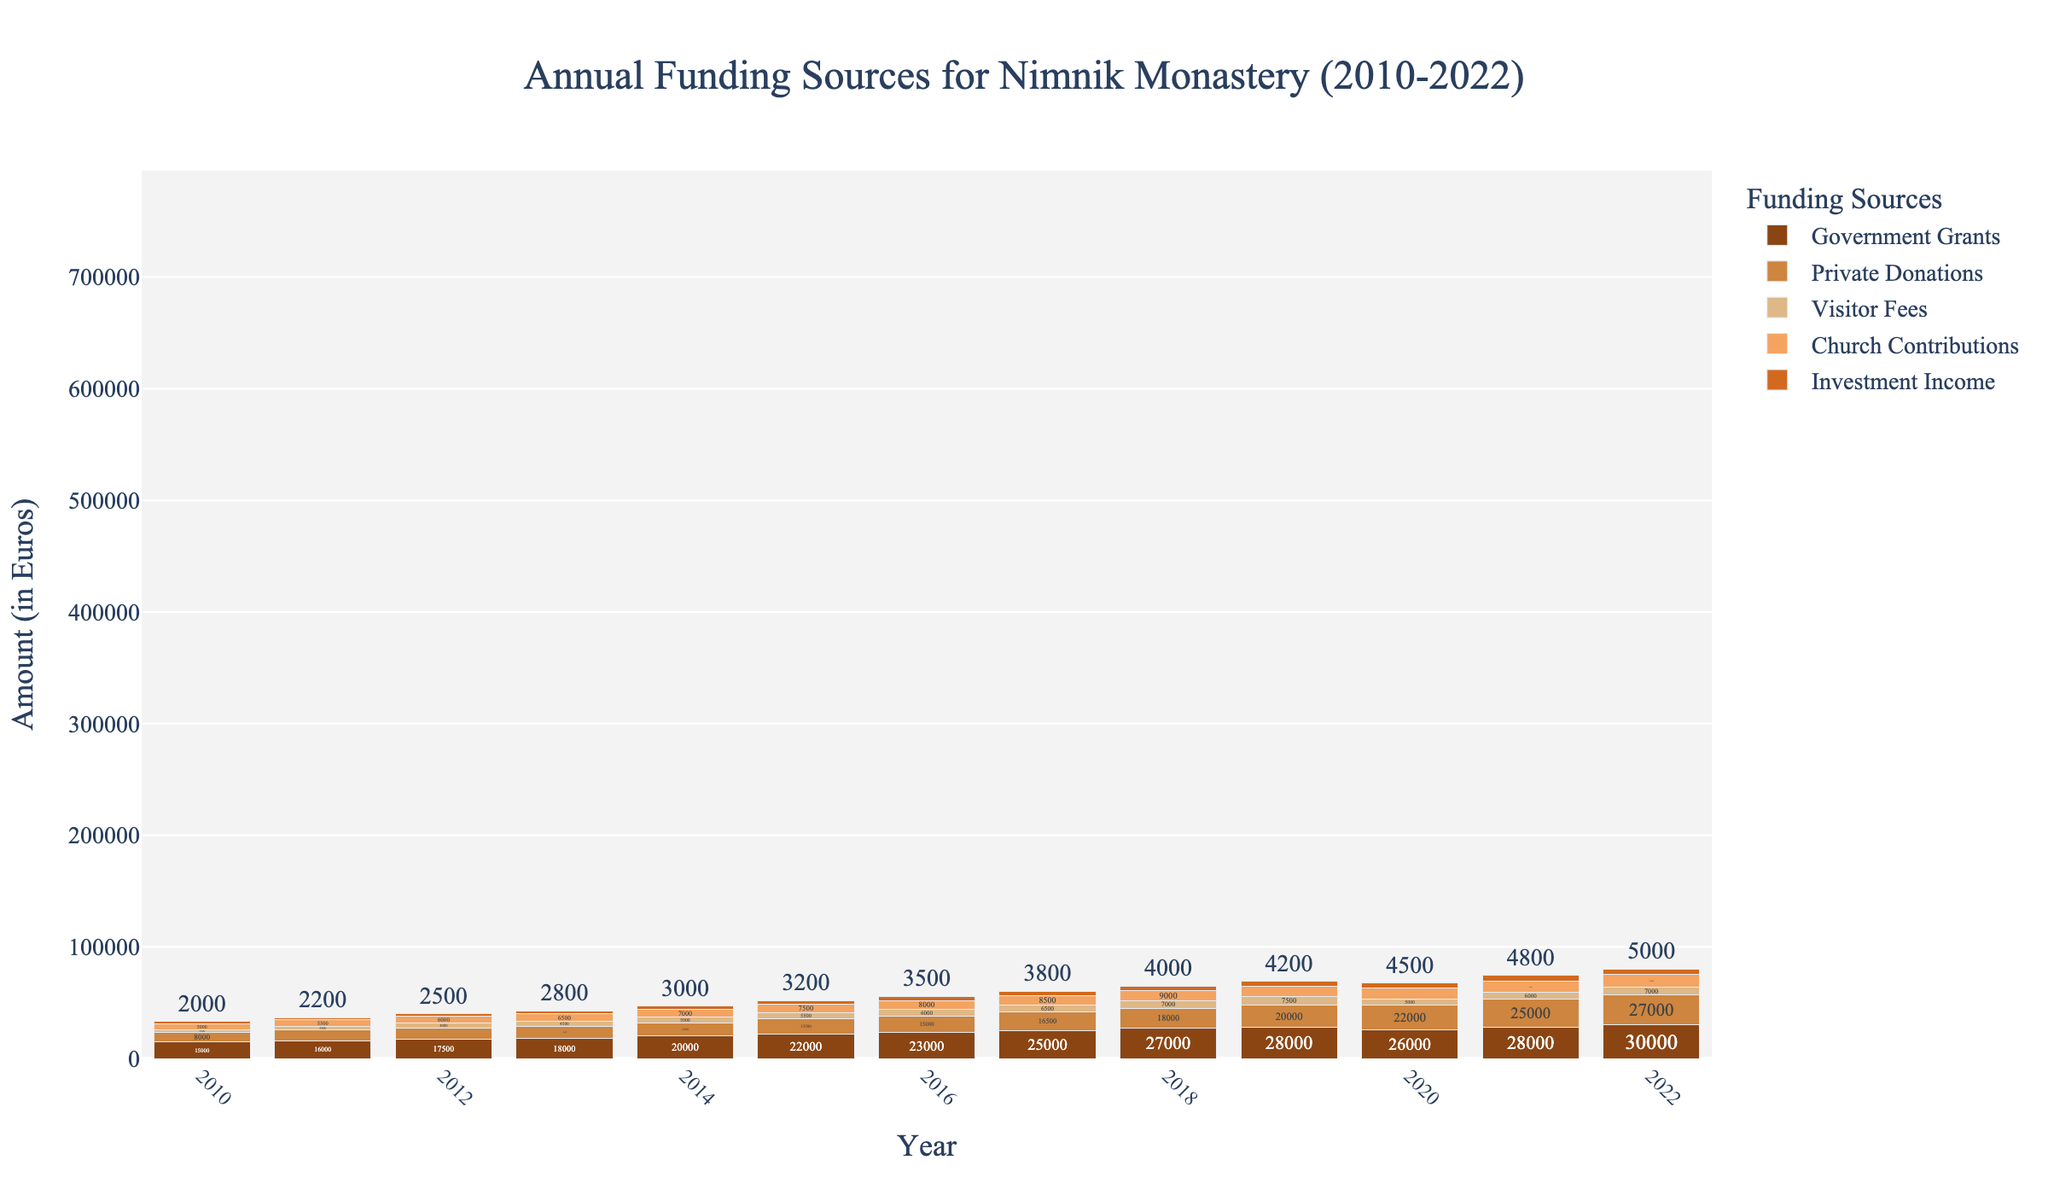What was the total amount of funding received in 2018? Sum the values for all funding sources in 2018: 27000 (Government Grants) + 18000 (Private Donations) + 7000 (Visitor Fees) + 9000 (Church Contributions) + 4000 (Investment Income) = 65000 Euros
Answer: 65000 Euros Which funding source saw the largest increase from 2010 to 2022? Calculate the change for each funding source from 2010 to 2022: Government Grants: 30000 - 15000 = 15000, Private Donations: 27000 - 8000 = 19000, Visitor Fees: 7000 - 3000 = 4000, Church Contributions: 11000 - 5000 = 6000, Investment Income: 5000 - 2000 = 3000. Private Donations had the largest increase.
Answer: Private Donations Did Visitor Fees ever surpass 7500 Euros? Inspect the Visitor Fees values for all years. The highest value for Visitor Fees is 7500 Euros in 2019, but it did not surpass 7500 Euros in any year.
Answer: No Which year had the highest combined funds from Government Grants and Church Contributions? Add the values for Government Grants and Church Contributions for each year and compare: 2010 (20000), 2011 (21500), 2012 (23500), 2013 (24500), 2014 (27000), 2015 (29500), 2016 (31000), 2017 (33500), 2018 (36000), 2019 (37500), 2020 (36000), 2021 (38500), 2022 (41000). The highest combined funds were in 2022.
Answer: 2022 Between 2015 and 2020, which funding source was the most stable in terms of amount received? Compare yearly values for each funding source from 2015 to 2020. Government Grants: 22000 to 26000, Private Donations: 13500 to 22000, Visitor Fees: 5500 to 5000, Church Contributions: 7500 to 10000, Investment Income: 3200 to 4500. Investment Income had the smallest variance.
Answer: Investment Income Which two funding sources had the closest amounts in 2022? Compare values for all funding sources in 2022 and find the two closest ones: Government Grants (30000), Private Donations (27000), Visitor Fees (7000), Church Contributions (11000), and Investment Income (5000). The closest values are Church Contributions (11000) and Visitor Fees (7000) with a difference of 4000 Euros.
Answer: Visitor Fees and Church Contributions From 2012 to 2016, which funding source grew the fastest in percentage terms? Calculate the percentage increase for each source between 2012 and 2016: Government Grants: (23000 - 17500) / 17500 * 100 ≈ 31.43%, Private Donations: (15000 - 10000) / 10000 * 100 = 50%, Visitor Fees: (6000 - 4000) / 4000 * 100 = 50%, Church Contributions: (8000 - 6000) / 6000 * 100 ≈ 33.33%, Investment Income: (3500 - 2500) / 2500 * 100 = 40%. Private Donations and Visitor Fees grew the fastest, both with a 50% increase.
Answer: Private Donations and Visitor Fees Which year had the smallest total funding? Sum the values for all funding sources for each year and compare: 2010 (33000), 2011 (36700), 2012 (40000), 2013 (42800), 2014 (47000), 2015 (51700), 2016 (55500), 2017 (61800), 2018 (65000), 2019 (69200), 2020 (66500), 2021 (74300), 2022 (80000). The smallest total funding occurred in 2010.
Answer: 2010 What was the average annual amount received from Government Grants from 2010 to 2022? Add the values for Government Grants from 2010 to 2022 and divide by the number of years: (15000 + 16000 + 17500 + 18000 + 20000 + 22000 + 23000 + 25000 + 27000 + 28000 + 26000 + 28000 + 30000) / 13 ≈ 22692.31 Euros
Answer: 22692.31 Euros 